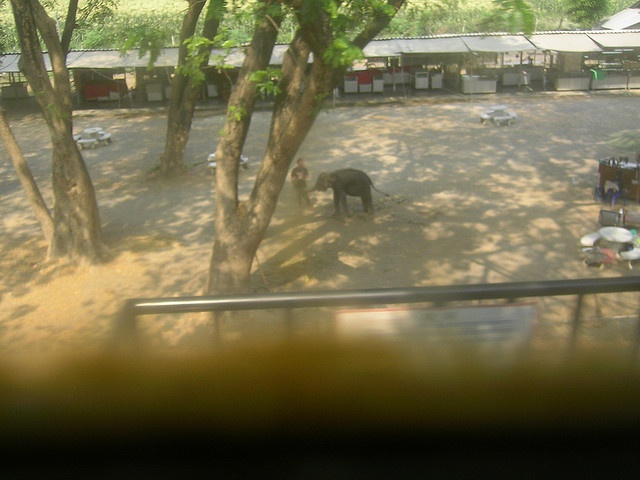Describe the objects in this image and their specific colors. I can see elephant in lightgreen, darkgreen, and gray tones, people in lightgreen, olive, and gray tones, dining table in lightgreen, lightgray, darkgray, and gray tones, dining table in lightgreen, darkgray, gray, and lightgray tones, and bench in lightgreen, gray, and tan tones in this image. 